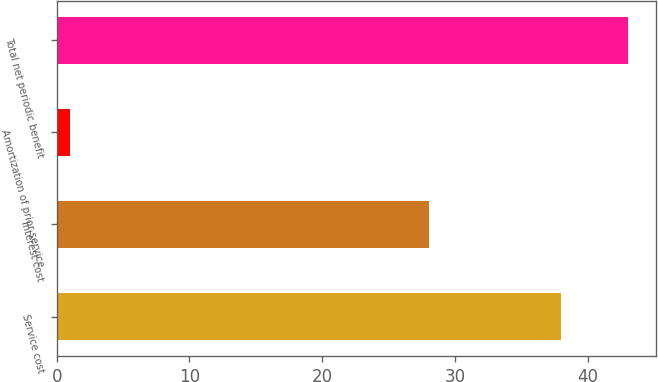Convert chart. <chart><loc_0><loc_0><loc_500><loc_500><bar_chart><fcel>Service cost<fcel>Interest cost<fcel>Amortization of prior service<fcel>Total net periodic benefit<nl><fcel>38<fcel>28<fcel>1<fcel>43<nl></chart> 